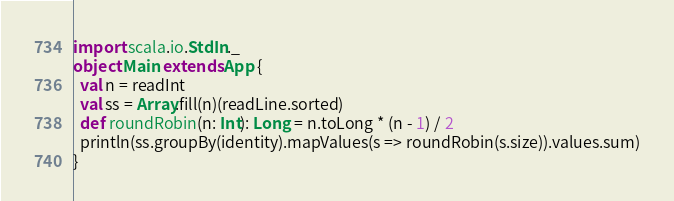Convert code to text. <code><loc_0><loc_0><loc_500><loc_500><_Scala_>import scala.io.StdIn._
object Main extends App {
  val n = readInt
  val ss = Array.fill(n)(readLine.sorted)
  def roundRobin(n: Int): Long = n.toLong * (n - 1) / 2
  println(ss.groupBy(identity).mapValues(s => roundRobin(s.size)).values.sum)
}</code> 